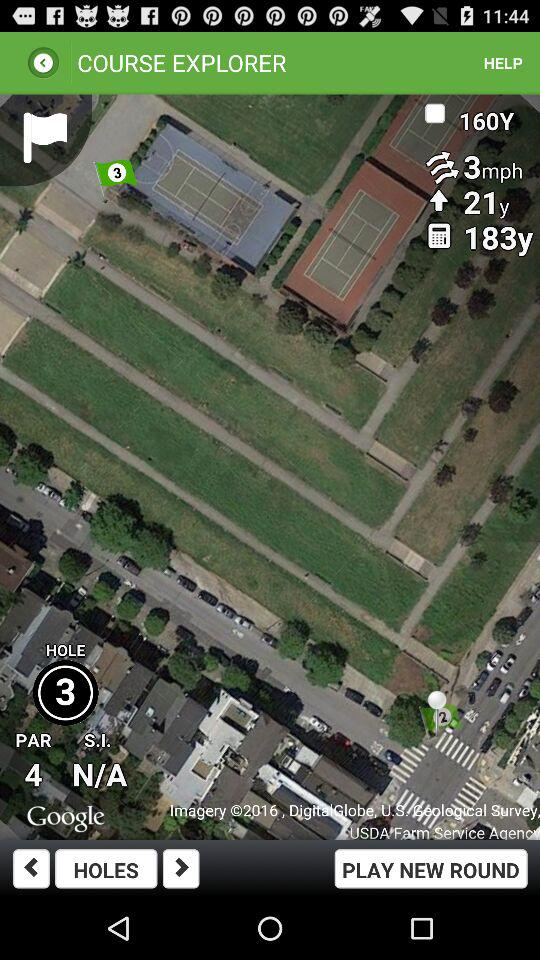What is the par for this hole?
Answer the question using a single word or phrase. 4 